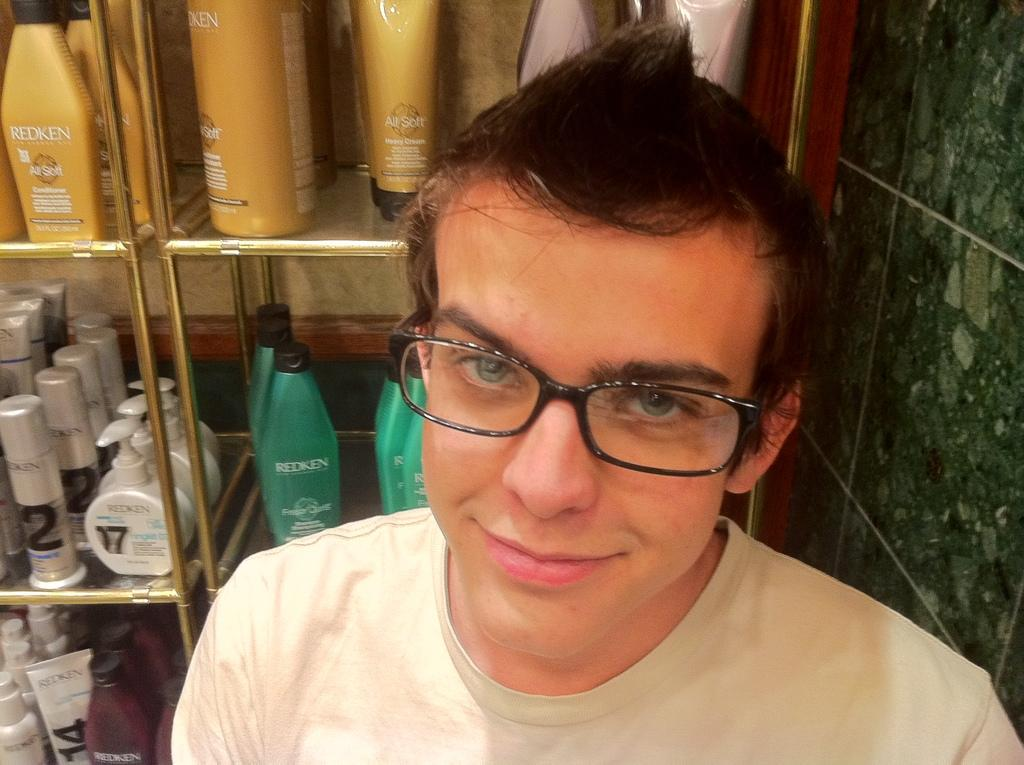Who or what is present in the image? There is a person in the image. What objects can be seen alongside the person? There are bottles and tubes in the image. How are the bottles and tubes arranged? The bottles and tubes are placed in racks. What type of prose is the person reading in the image? There is no indication in the image that the person is reading any prose, as the focus is on the bottles, tubes, and racks. 